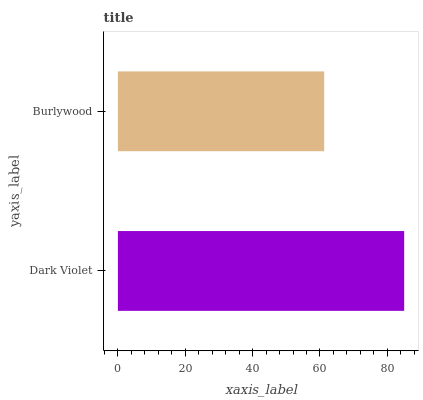Is Burlywood the minimum?
Answer yes or no. Yes. Is Dark Violet the maximum?
Answer yes or no. Yes. Is Burlywood the maximum?
Answer yes or no. No. Is Dark Violet greater than Burlywood?
Answer yes or no. Yes. Is Burlywood less than Dark Violet?
Answer yes or no. Yes. Is Burlywood greater than Dark Violet?
Answer yes or no. No. Is Dark Violet less than Burlywood?
Answer yes or no. No. Is Dark Violet the high median?
Answer yes or no. Yes. Is Burlywood the low median?
Answer yes or no. Yes. Is Burlywood the high median?
Answer yes or no. No. Is Dark Violet the low median?
Answer yes or no. No. 